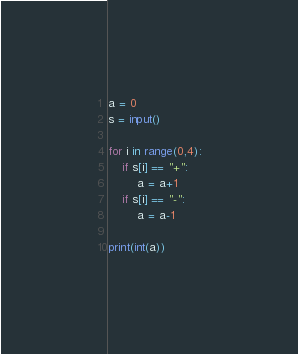Convert code to text. <code><loc_0><loc_0><loc_500><loc_500><_Python_>a = 0
s = input()

for i in range(0,4):
    if s[i] == "+":
        a = a+1
    if s[i] == "-":
        a = a-1
        
print(int(a))</code> 